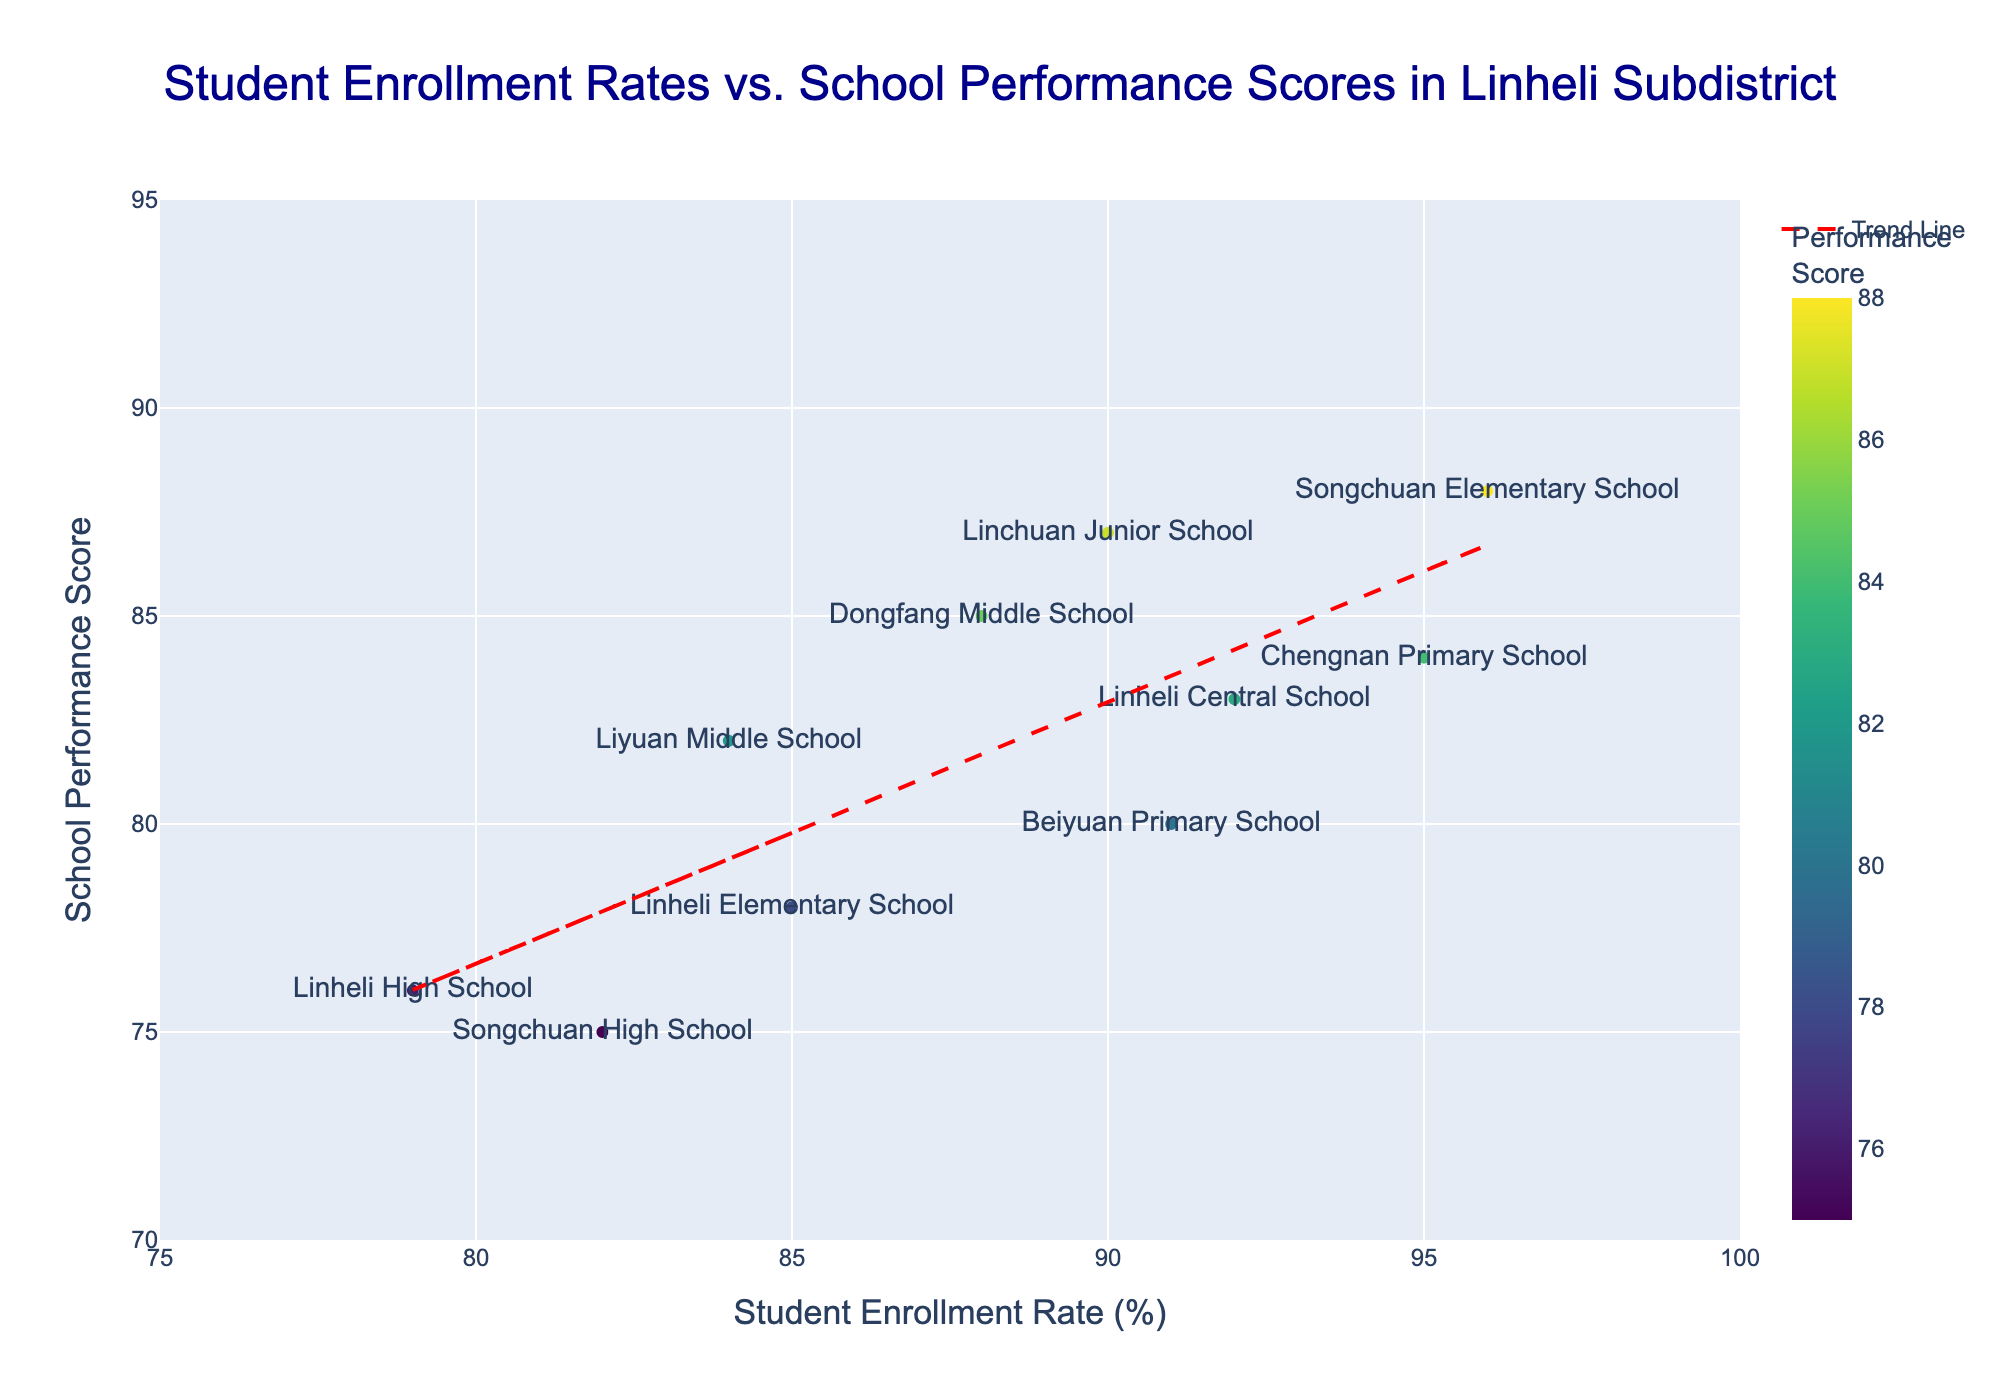What's the title of this scatter plot? The title of the scatter plot is usually displayed prominently at the top of the figure.
Answer: Student Enrollment Rates vs. School Performance Scores in Linheli Subdistrict What's the range of Student Enrollment Rates on the x-axis? The x-axis has tick marks that help indicate the range of values it covers. The tick marks range from 75% to 100%.
Answer: 75% to 100% What is the color gradient indicating in the scatter plot? The figure uses a color gradient, which is usually shown in a color bar next to the figure. The color bar title indicates that it represents the School Performance Scores.
Answer: School Performance Scores How many schools are represented in this scatter plot? By counting each individual point in the scatter plot, which represents a school, you end up with the total number of schools.
Answer: 10 Which school has the highest Student Enrollment Rate and what is its Performance Score? By examining the highest value on the x-axis (Student Enrollment Rate) and cross-referencing with the corresponding point's y-value (Performance Score), we identify that the school is "Songchuan Elementary School" with an enrollment rate of 96% and a performance score of 88.
Answer: Songchuan Elementary School, 88 What is the trend line indicating in the scatter plot? The trend line, often added to indicate the general direction that the data points follow, is sloping upwards. This indicates a positive relationship between Student Enrollment Rates and School Performance Scores.
Answer: Positive relationship What is the average School Performance Score of Linheli Subdistrict schools? First, sum up all the School Performance Scores: 78 + 83 + 85 + 76 + 80 + 82 + 88 + 75 + 87 + 84 = 818. Then divide by the number of schools (10). The average score is 818 / 10 = 81.8.
Answer: 81.8 Which school has the lowest School Performance Score and what is its Student Enrollment Rate? By examining the lowest value on the y-axis (School Performance Score) and cross-referencing with the corresponding point's x-value (Student Enrollment Rate), we identify that the school is "Songchuan High School" with a performance score of 75 and an enrollment rate of 82%.
Answer: Songchuan High School, 82% How many schools have a Student Enrollment Rate greater than 90%? By counting the number of points that lie to the right of the 90% mark on the x-axis, we see several schools: Linheli Central School, Beiyuan Primary School, Songchuan Elementary School, Linchuan Junior School, Chengnan Primary School.
Answer: 5 What does the color red represent in the trend line? By observing the color of the trend line, which is typically highlighted and often explained in the figure legend or description, we understand that red is used to visually distinguish the trend line from the data points.
Answer: Trend Line 